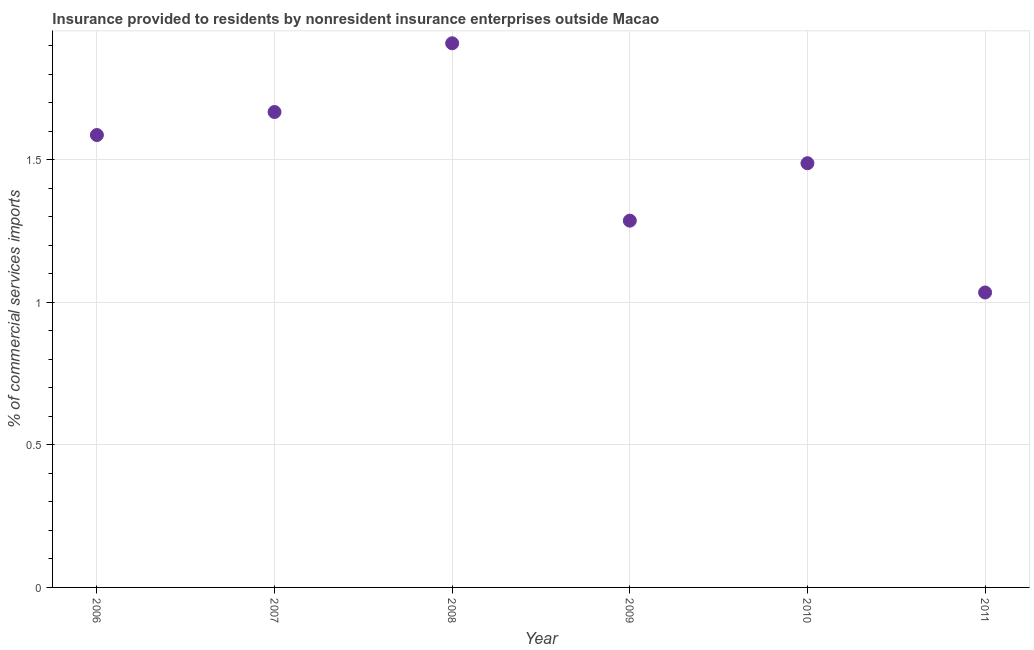What is the insurance provided by non-residents in 2008?
Your response must be concise. 1.91. Across all years, what is the maximum insurance provided by non-residents?
Ensure brevity in your answer.  1.91. Across all years, what is the minimum insurance provided by non-residents?
Your answer should be compact. 1.03. In which year was the insurance provided by non-residents minimum?
Ensure brevity in your answer.  2011. What is the sum of the insurance provided by non-residents?
Make the answer very short. 8.97. What is the difference between the insurance provided by non-residents in 2007 and 2010?
Provide a short and direct response. 0.18. What is the average insurance provided by non-residents per year?
Your answer should be compact. 1.5. What is the median insurance provided by non-residents?
Give a very brief answer. 1.54. In how many years, is the insurance provided by non-residents greater than 0.2 %?
Provide a succinct answer. 6. What is the ratio of the insurance provided by non-residents in 2006 to that in 2011?
Provide a short and direct response. 1.53. Is the insurance provided by non-residents in 2010 less than that in 2011?
Offer a terse response. No. Is the difference between the insurance provided by non-residents in 2008 and 2011 greater than the difference between any two years?
Keep it short and to the point. Yes. What is the difference between the highest and the second highest insurance provided by non-residents?
Your answer should be compact. 0.24. Is the sum of the insurance provided by non-residents in 2008 and 2009 greater than the maximum insurance provided by non-residents across all years?
Offer a very short reply. Yes. What is the difference between the highest and the lowest insurance provided by non-residents?
Give a very brief answer. 0.87. How many dotlines are there?
Provide a short and direct response. 1. What is the difference between two consecutive major ticks on the Y-axis?
Provide a short and direct response. 0.5. What is the title of the graph?
Your response must be concise. Insurance provided to residents by nonresident insurance enterprises outside Macao. What is the label or title of the Y-axis?
Offer a terse response. % of commercial services imports. What is the % of commercial services imports in 2006?
Provide a short and direct response. 1.59. What is the % of commercial services imports in 2007?
Your answer should be compact. 1.67. What is the % of commercial services imports in 2008?
Offer a terse response. 1.91. What is the % of commercial services imports in 2009?
Make the answer very short. 1.29. What is the % of commercial services imports in 2010?
Make the answer very short. 1.49. What is the % of commercial services imports in 2011?
Provide a short and direct response. 1.03. What is the difference between the % of commercial services imports in 2006 and 2007?
Your answer should be very brief. -0.08. What is the difference between the % of commercial services imports in 2006 and 2008?
Your response must be concise. -0.32. What is the difference between the % of commercial services imports in 2006 and 2009?
Give a very brief answer. 0.3. What is the difference between the % of commercial services imports in 2006 and 2010?
Your response must be concise. 0.1. What is the difference between the % of commercial services imports in 2006 and 2011?
Your answer should be very brief. 0.55. What is the difference between the % of commercial services imports in 2007 and 2008?
Make the answer very short. -0.24. What is the difference between the % of commercial services imports in 2007 and 2009?
Offer a terse response. 0.38. What is the difference between the % of commercial services imports in 2007 and 2010?
Your answer should be compact. 0.18. What is the difference between the % of commercial services imports in 2007 and 2011?
Offer a very short reply. 0.63. What is the difference between the % of commercial services imports in 2008 and 2009?
Your answer should be compact. 0.62. What is the difference between the % of commercial services imports in 2008 and 2010?
Offer a very short reply. 0.42. What is the difference between the % of commercial services imports in 2008 and 2011?
Offer a terse response. 0.87. What is the difference between the % of commercial services imports in 2009 and 2010?
Keep it short and to the point. -0.2. What is the difference between the % of commercial services imports in 2009 and 2011?
Keep it short and to the point. 0.25. What is the difference between the % of commercial services imports in 2010 and 2011?
Offer a very short reply. 0.45. What is the ratio of the % of commercial services imports in 2006 to that in 2008?
Keep it short and to the point. 0.83. What is the ratio of the % of commercial services imports in 2006 to that in 2009?
Give a very brief answer. 1.23. What is the ratio of the % of commercial services imports in 2006 to that in 2010?
Offer a very short reply. 1.07. What is the ratio of the % of commercial services imports in 2006 to that in 2011?
Make the answer very short. 1.53. What is the ratio of the % of commercial services imports in 2007 to that in 2008?
Provide a succinct answer. 0.87. What is the ratio of the % of commercial services imports in 2007 to that in 2009?
Provide a short and direct response. 1.3. What is the ratio of the % of commercial services imports in 2007 to that in 2010?
Offer a very short reply. 1.12. What is the ratio of the % of commercial services imports in 2007 to that in 2011?
Your answer should be compact. 1.61. What is the ratio of the % of commercial services imports in 2008 to that in 2009?
Your response must be concise. 1.48. What is the ratio of the % of commercial services imports in 2008 to that in 2010?
Your answer should be compact. 1.28. What is the ratio of the % of commercial services imports in 2008 to that in 2011?
Your answer should be very brief. 1.84. What is the ratio of the % of commercial services imports in 2009 to that in 2010?
Offer a very short reply. 0.86. What is the ratio of the % of commercial services imports in 2009 to that in 2011?
Provide a succinct answer. 1.24. What is the ratio of the % of commercial services imports in 2010 to that in 2011?
Ensure brevity in your answer.  1.44. 